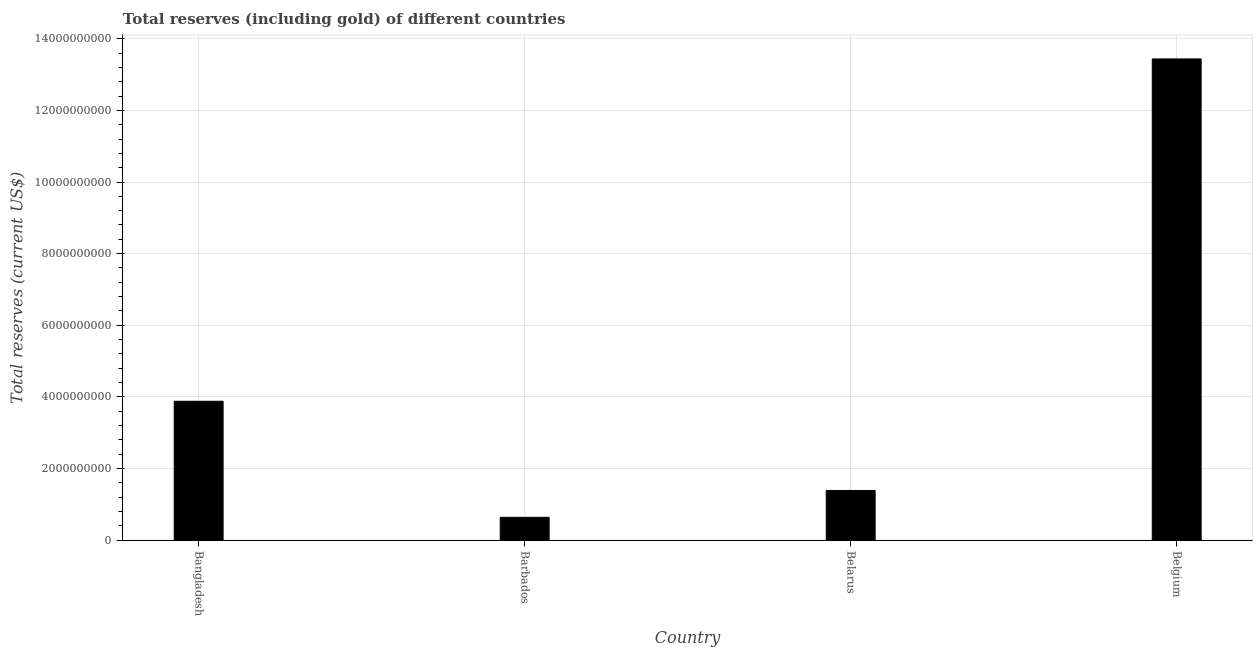Does the graph contain any zero values?
Your answer should be very brief. No. Does the graph contain grids?
Give a very brief answer. Yes. What is the title of the graph?
Your answer should be compact. Total reserves (including gold) of different countries. What is the label or title of the X-axis?
Your answer should be compact. Country. What is the label or title of the Y-axis?
Provide a succinct answer. Total reserves (current US$). What is the total reserves (including gold) in Bangladesh?
Ensure brevity in your answer.  3.88e+09. Across all countries, what is the maximum total reserves (including gold)?
Give a very brief answer. 1.34e+1. Across all countries, what is the minimum total reserves (including gold)?
Keep it short and to the point. 6.36e+08. In which country was the total reserves (including gold) minimum?
Provide a short and direct response. Barbados. What is the sum of the total reserves (including gold)?
Keep it short and to the point. 1.93e+1. What is the difference between the total reserves (including gold) in Barbados and Belarus?
Offer a very short reply. -7.50e+08. What is the average total reserves (including gold) per country?
Provide a succinct answer. 4.83e+09. What is the median total reserves (including gold)?
Offer a terse response. 2.63e+09. What is the ratio of the total reserves (including gold) in Bangladesh to that in Belgium?
Ensure brevity in your answer.  0.29. Is the difference between the total reserves (including gold) in Barbados and Belarus greater than the difference between any two countries?
Your answer should be compact. No. What is the difference between the highest and the second highest total reserves (including gold)?
Keep it short and to the point. 9.56e+09. What is the difference between the highest and the lowest total reserves (including gold)?
Provide a short and direct response. 1.28e+1. In how many countries, is the total reserves (including gold) greater than the average total reserves (including gold) taken over all countries?
Ensure brevity in your answer.  1. How many bars are there?
Your answer should be very brief. 4. Are the values on the major ticks of Y-axis written in scientific E-notation?
Make the answer very short. No. What is the Total reserves (current US$) of Bangladesh?
Ensure brevity in your answer.  3.88e+09. What is the Total reserves (current US$) in Barbados?
Your answer should be compact. 6.36e+08. What is the Total reserves (current US$) of Belarus?
Offer a very short reply. 1.39e+09. What is the Total reserves (current US$) in Belgium?
Give a very brief answer. 1.34e+1. What is the difference between the Total reserves (current US$) in Bangladesh and Barbados?
Offer a very short reply. 3.24e+09. What is the difference between the Total reserves (current US$) in Bangladesh and Belarus?
Your response must be concise. 2.49e+09. What is the difference between the Total reserves (current US$) in Bangladesh and Belgium?
Offer a terse response. -9.56e+09. What is the difference between the Total reserves (current US$) in Barbados and Belarus?
Your answer should be compact. -7.50e+08. What is the difference between the Total reserves (current US$) in Barbados and Belgium?
Make the answer very short. -1.28e+1. What is the difference between the Total reserves (current US$) in Belarus and Belgium?
Keep it short and to the point. -1.21e+1. What is the ratio of the Total reserves (current US$) in Bangladesh to that in Barbados?
Offer a very short reply. 6.09. What is the ratio of the Total reserves (current US$) in Bangladesh to that in Belarus?
Offer a terse response. 2.8. What is the ratio of the Total reserves (current US$) in Bangladesh to that in Belgium?
Your answer should be compact. 0.29. What is the ratio of the Total reserves (current US$) in Barbados to that in Belarus?
Your answer should be very brief. 0.46. What is the ratio of the Total reserves (current US$) in Barbados to that in Belgium?
Offer a very short reply. 0.05. What is the ratio of the Total reserves (current US$) in Belarus to that in Belgium?
Your answer should be compact. 0.1. 